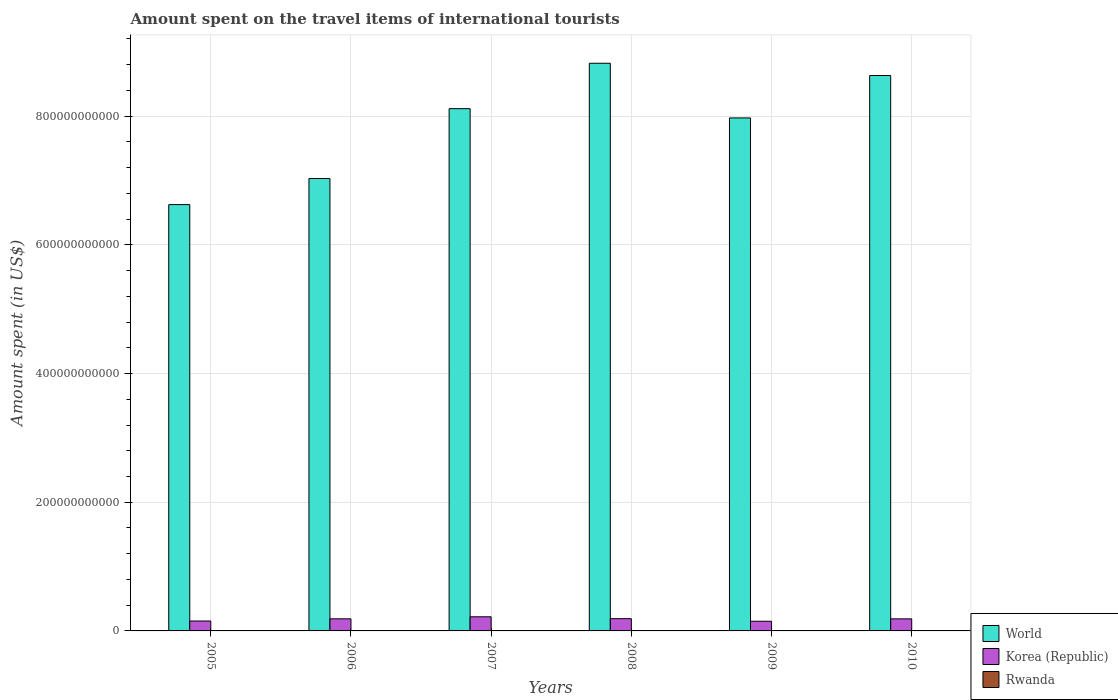How many groups of bars are there?
Provide a short and direct response. 6. Are the number of bars on each tick of the X-axis equal?
Offer a very short reply. Yes. How many bars are there on the 1st tick from the left?
Give a very brief answer. 3. How many bars are there on the 1st tick from the right?
Your answer should be compact. 3. In how many cases, is the number of bars for a given year not equal to the number of legend labels?
Make the answer very short. 0. What is the amount spent on the travel items of international tourists in World in 2006?
Give a very brief answer. 7.03e+11. Across all years, what is the maximum amount spent on the travel items of international tourists in Korea (Republic)?
Offer a very short reply. 2.20e+1. Across all years, what is the minimum amount spent on the travel items of international tourists in World?
Give a very brief answer. 6.63e+11. What is the total amount spent on the travel items of international tourists in Rwanda in the graph?
Provide a succinct answer. 3.44e+08. What is the difference between the amount spent on the travel items of international tourists in Korea (Republic) in 2008 and that in 2010?
Keep it short and to the point. 2.90e+08. What is the difference between the amount spent on the travel items of international tourists in Korea (Republic) in 2010 and the amount spent on the travel items of international tourists in World in 2005?
Your answer should be very brief. -6.44e+11. What is the average amount spent on the travel items of international tourists in Rwanda per year?
Provide a short and direct response. 5.73e+07. In the year 2005, what is the difference between the amount spent on the travel items of international tourists in Korea (Republic) and amount spent on the travel items of international tourists in Rwanda?
Give a very brief answer. 1.54e+1. In how many years, is the amount spent on the travel items of international tourists in Rwanda greater than 200000000000 US$?
Ensure brevity in your answer.  0. What is the ratio of the amount spent on the travel items of international tourists in World in 2007 to that in 2008?
Your answer should be very brief. 0.92. What is the difference between the highest and the second highest amount spent on the travel items of international tourists in Rwanda?
Provide a succinct answer. 5.00e+06. What is the difference between the highest and the lowest amount spent on the travel items of international tourists in World?
Ensure brevity in your answer.  2.20e+11. What does the 3rd bar from the left in 2006 represents?
Your answer should be compact. Rwanda. What does the 1st bar from the right in 2005 represents?
Offer a very short reply. Rwanda. Is it the case that in every year, the sum of the amount spent on the travel items of international tourists in Rwanda and amount spent on the travel items of international tourists in World is greater than the amount spent on the travel items of international tourists in Korea (Republic)?
Keep it short and to the point. Yes. How many bars are there?
Your answer should be compact. 18. Are all the bars in the graph horizontal?
Your answer should be compact. No. What is the difference between two consecutive major ticks on the Y-axis?
Provide a succinct answer. 2.00e+11. Are the values on the major ticks of Y-axis written in scientific E-notation?
Provide a short and direct response. No. Does the graph contain grids?
Offer a terse response. Yes. How many legend labels are there?
Make the answer very short. 3. How are the legend labels stacked?
Give a very brief answer. Vertical. What is the title of the graph?
Your answer should be compact. Amount spent on the travel items of international tourists. Does "Channel Islands" appear as one of the legend labels in the graph?
Provide a short and direct response. No. What is the label or title of the X-axis?
Your answer should be compact. Years. What is the label or title of the Y-axis?
Offer a very short reply. Amount spent (in US$). What is the Amount spent (in US$) in World in 2005?
Make the answer very short. 6.63e+11. What is the Amount spent (in US$) in Korea (Republic) in 2005?
Give a very brief answer. 1.54e+1. What is the Amount spent (in US$) of Rwanda in 2005?
Offer a very short reply. 3.70e+07. What is the Amount spent (in US$) in World in 2006?
Your answer should be very brief. 7.03e+11. What is the Amount spent (in US$) in Korea (Republic) in 2006?
Keep it short and to the point. 1.88e+1. What is the Amount spent (in US$) in Rwanda in 2006?
Offer a very short reply. 4.10e+07. What is the Amount spent (in US$) in World in 2007?
Provide a short and direct response. 8.12e+11. What is the Amount spent (in US$) in Korea (Republic) in 2007?
Your answer should be compact. 2.20e+1. What is the Amount spent (in US$) in Rwanda in 2007?
Provide a succinct answer. 4.70e+07. What is the Amount spent (in US$) in World in 2008?
Your answer should be very brief. 8.82e+11. What is the Amount spent (in US$) of Korea (Republic) in 2008?
Your response must be concise. 1.91e+1. What is the Amount spent (in US$) of Rwanda in 2008?
Give a very brief answer. 7.00e+07. What is the Amount spent (in US$) of World in 2009?
Make the answer very short. 7.97e+11. What is the Amount spent (in US$) in Korea (Republic) in 2009?
Offer a very short reply. 1.50e+1. What is the Amount spent (in US$) in Rwanda in 2009?
Your answer should be very brief. 7.20e+07. What is the Amount spent (in US$) of World in 2010?
Provide a succinct answer. 8.63e+11. What is the Amount spent (in US$) of Korea (Republic) in 2010?
Offer a very short reply. 1.88e+1. What is the Amount spent (in US$) of Rwanda in 2010?
Offer a very short reply. 7.70e+07. Across all years, what is the maximum Amount spent (in US$) in World?
Your response must be concise. 8.82e+11. Across all years, what is the maximum Amount spent (in US$) of Korea (Republic)?
Provide a short and direct response. 2.20e+1. Across all years, what is the maximum Amount spent (in US$) of Rwanda?
Provide a short and direct response. 7.70e+07. Across all years, what is the minimum Amount spent (in US$) of World?
Offer a terse response. 6.63e+11. Across all years, what is the minimum Amount spent (in US$) of Korea (Republic)?
Provide a succinct answer. 1.50e+1. Across all years, what is the minimum Amount spent (in US$) of Rwanda?
Provide a succinct answer. 3.70e+07. What is the total Amount spent (in US$) in World in the graph?
Provide a short and direct response. 4.72e+12. What is the total Amount spent (in US$) in Korea (Republic) in the graph?
Ensure brevity in your answer.  1.09e+11. What is the total Amount spent (in US$) of Rwanda in the graph?
Give a very brief answer. 3.44e+08. What is the difference between the Amount spent (in US$) in World in 2005 and that in 2006?
Offer a terse response. -4.05e+1. What is the difference between the Amount spent (in US$) in Korea (Republic) in 2005 and that in 2006?
Offer a very short reply. -3.40e+09. What is the difference between the Amount spent (in US$) in World in 2005 and that in 2007?
Your response must be concise. -1.49e+11. What is the difference between the Amount spent (in US$) in Korea (Republic) in 2005 and that in 2007?
Provide a succinct answer. -6.55e+09. What is the difference between the Amount spent (in US$) of Rwanda in 2005 and that in 2007?
Provide a short and direct response. -1.00e+07. What is the difference between the Amount spent (in US$) in World in 2005 and that in 2008?
Your answer should be very brief. -2.20e+11. What is the difference between the Amount spent (in US$) in Korea (Republic) in 2005 and that in 2008?
Provide a short and direct response. -3.65e+09. What is the difference between the Amount spent (in US$) of Rwanda in 2005 and that in 2008?
Your answer should be compact. -3.30e+07. What is the difference between the Amount spent (in US$) of World in 2005 and that in 2009?
Give a very brief answer. -1.35e+11. What is the difference between the Amount spent (in US$) of Korea (Republic) in 2005 and that in 2009?
Make the answer very short. 3.71e+08. What is the difference between the Amount spent (in US$) of Rwanda in 2005 and that in 2009?
Your answer should be very brief. -3.50e+07. What is the difference between the Amount spent (in US$) of World in 2005 and that in 2010?
Your answer should be compact. -2.01e+11. What is the difference between the Amount spent (in US$) of Korea (Republic) in 2005 and that in 2010?
Keep it short and to the point. -3.36e+09. What is the difference between the Amount spent (in US$) in Rwanda in 2005 and that in 2010?
Offer a terse response. -4.00e+07. What is the difference between the Amount spent (in US$) of World in 2006 and that in 2007?
Your answer should be compact. -1.09e+11. What is the difference between the Amount spent (in US$) in Korea (Republic) in 2006 and that in 2007?
Your answer should be very brief. -3.15e+09. What is the difference between the Amount spent (in US$) of Rwanda in 2006 and that in 2007?
Make the answer very short. -6.00e+06. What is the difference between the Amount spent (in US$) in World in 2006 and that in 2008?
Provide a short and direct response. -1.79e+11. What is the difference between the Amount spent (in US$) in Korea (Republic) in 2006 and that in 2008?
Your response must be concise. -2.47e+08. What is the difference between the Amount spent (in US$) of Rwanda in 2006 and that in 2008?
Provide a short and direct response. -2.90e+07. What is the difference between the Amount spent (in US$) in World in 2006 and that in 2009?
Your answer should be very brief. -9.41e+1. What is the difference between the Amount spent (in US$) of Korea (Republic) in 2006 and that in 2009?
Ensure brevity in your answer.  3.77e+09. What is the difference between the Amount spent (in US$) in Rwanda in 2006 and that in 2009?
Ensure brevity in your answer.  -3.10e+07. What is the difference between the Amount spent (in US$) in World in 2006 and that in 2010?
Give a very brief answer. -1.60e+11. What is the difference between the Amount spent (in US$) in Korea (Republic) in 2006 and that in 2010?
Your answer should be very brief. 4.30e+07. What is the difference between the Amount spent (in US$) in Rwanda in 2006 and that in 2010?
Offer a terse response. -3.60e+07. What is the difference between the Amount spent (in US$) of World in 2007 and that in 2008?
Provide a short and direct response. -7.06e+1. What is the difference between the Amount spent (in US$) of Korea (Republic) in 2007 and that in 2008?
Keep it short and to the point. 2.90e+09. What is the difference between the Amount spent (in US$) in Rwanda in 2007 and that in 2008?
Offer a very short reply. -2.30e+07. What is the difference between the Amount spent (in US$) of World in 2007 and that in 2009?
Give a very brief answer. 1.44e+1. What is the difference between the Amount spent (in US$) in Korea (Republic) in 2007 and that in 2009?
Ensure brevity in your answer.  6.92e+09. What is the difference between the Amount spent (in US$) in Rwanda in 2007 and that in 2009?
Provide a succinct answer. -2.50e+07. What is the difference between the Amount spent (in US$) of World in 2007 and that in 2010?
Your answer should be compact. -5.15e+1. What is the difference between the Amount spent (in US$) of Korea (Republic) in 2007 and that in 2010?
Your answer should be very brief. 3.19e+09. What is the difference between the Amount spent (in US$) of Rwanda in 2007 and that in 2010?
Ensure brevity in your answer.  -3.00e+07. What is the difference between the Amount spent (in US$) in World in 2008 and that in 2009?
Ensure brevity in your answer.  8.50e+1. What is the difference between the Amount spent (in US$) of Korea (Republic) in 2008 and that in 2009?
Provide a short and direct response. 4.02e+09. What is the difference between the Amount spent (in US$) in Rwanda in 2008 and that in 2009?
Give a very brief answer. -2.00e+06. What is the difference between the Amount spent (in US$) in World in 2008 and that in 2010?
Keep it short and to the point. 1.91e+1. What is the difference between the Amount spent (in US$) of Korea (Republic) in 2008 and that in 2010?
Your answer should be very brief. 2.90e+08. What is the difference between the Amount spent (in US$) in Rwanda in 2008 and that in 2010?
Provide a short and direct response. -7.00e+06. What is the difference between the Amount spent (in US$) of World in 2009 and that in 2010?
Ensure brevity in your answer.  -6.59e+1. What is the difference between the Amount spent (in US$) of Korea (Republic) in 2009 and that in 2010?
Offer a terse response. -3.73e+09. What is the difference between the Amount spent (in US$) of Rwanda in 2009 and that in 2010?
Offer a terse response. -5.00e+06. What is the difference between the Amount spent (in US$) in World in 2005 and the Amount spent (in US$) in Korea (Republic) in 2006?
Offer a terse response. 6.44e+11. What is the difference between the Amount spent (in US$) of World in 2005 and the Amount spent (in US$) of Rwanda in 2006?
Ensure brevity in your answer.  6.62e+11. What is the difference between the Amount spent (in US$) in Korea (Republic) in 2005 and the Amount spent (in US$) in Rwanda in 2006?
Ensure brevity in your answer.  1.54e+1. What is the difference between the Amount spent (in US$) of World in 2005 and the Amount spent (in US$) of Korea (Republic) in 2007?
Offer a very short reply. 6.41e+11. What is the difference between the Amount spent (in US$) of World in 2005 and the Amount spent (in US$) of Rwanda in 2007?
Keep it short and to the point. 6.62e+11. What is the difference between the Amount spent (in US$) of Korea (Republic) in 2005 and the Amount spent (in US$) of Rwanda in 2007?
Give a very brief answer. 1.54e+1. What is the difference between the Amount spent (in US$) in World in 2005 and the Amount spent (in US$) in Korea (Republic) in 2008?
Offer a terse response. 6.43e+11. What is the difference between the Amount spent (in US$) of World in 2005 and the Amount spent (in US$) of Rwanda in 2008?
Your response must be concise. 6.62e+11. What is the difference between the Amount spent (in US$) in Korea (Republic) in 2005 and the Amount spent (in US$) in Rwanda in 2008?
Offer a terse response. 1.53e+1. What is the difference between the Amount spent (in US$) in World in 2005 and the Amount spent (in US$) in Korea (Republic) in 2009?
Make the answer very short. 6.47e+11. What is the difference between the Amount spent (in US$) in World in 2005 and the Amount spent (in US$) in Rwanda in 2009?
Offer a very short reply. 6.62e+11. What is the difference between the Amount spent (in US$) of Korea (Republic) in 2005 and the Amount spent (in US$) of Rwanda in 2009?
Your response must be concise. 1.53e+1. What is the difference between the Amount spent (in US$) in World in 2005 and the Amount spent (in US$) in Korea (Republic) in 2010?
Provide a short and direct response. 6.44e+11. What is the difference between the Amount spent (in US$) in World in 2005 and the Amount spent (in US$) in Rwanda in 2010?
Offer a very short reply. 6.62e+11. What is the difference between the Amount spent (in US$) of Korea (Republic) in 2005 and the Amount spent (in US$) of Rwanda in 2010?
Your response must be concise. 1.53e+1. What is the difference between the Amount spent (in US$) in World in 2006 and the Amount spent (in US$) in Korea (Republic) in 2007?
Your answer should be compact. 6.81e+11. What is the difference between the Amount spent (in US$) of World in 2006 and the Amount spent (in US$) of Rwanda in 2007?
Your answer should be very brief. 7.03e+11. What is the difference between the Amount spent (in US$) of Korea (Republic) in 2006 and the Amount spent (in US$) of Rwanda in 2007?
Provide a succinct answer. 1.88e+1. What is the difference between the Amount spent (in US$) in World in 2006 and the Amount spent (in US$) in Korea (Republic) in 2008?
Provide a succinct answer. 6.84e+11. What is the difference between the Amount spent (in US$) of World in 2006 and the Amount spent (in US$) of Rwanda in 2008?
Offer a terse response. 7.03e+11. What is the difference between the Amount spent (in US$) of Korea (Republic) in 2006 and the Amount spent (in US$) of Rwanda in 2008?
Offer a terse response. 1.87e+1. What is the difference between the Amount spent (in US$) in World in 2006 and the Amount spent (in US$) in Korea (Republic) in 2009?
Keep it short and to the point. 6.88e+11. What is the difference between the Amount spent (in US$) of World in 2006 and the Amount spent (in US$) of Rwanda in 2009?
Give a very brief answer. 7.03e+11. What is the difference between the Amount spent (in US$) of Korea (Republic) in 2006 and the Amount spent (in US$) of Rwanda in 2009?
Provide a short and direct response. 1.87e+1. What is the difference between the Amount spent (in US$) of World in 2006 and the Amount spent (in US$) of Korea (Republic) in 2010?
Provide a succinct answer. 6.84e+11. What is the difference between the Amount spent (in US$) in World in 2006 and the Amount spent (in US$) in Rwanda in 2010?
Your answer should be very brief. 7.03e+11. What is the difference between the Amount spent (in US$) of Korea (Republic) in 2006 and the Amount spent (in US$) of Rwanda in 2010?
Offer a very short reply. 1.87e+1. What is the difference between the Amount spent (in US$) of World in 2007 and the Amount spent (in US$) of Korea (Republic) in 2008?
Your answer should be very brief. 7.93e+11. What is the difference between the Amount spent (in US$) of World in 2007 and the Amount spent (in US$) of Rwanda in 2008?
Your response must be concise. 8.12e+11. What is the difference between the Amount spent (in US$) in Korea (Republic) in 2007 and the Amount spent (in US$) in Rwanda in 2008?
Ensure brevity in your answer.  2.19e+1. What is the difference between the Amount spent (in US$) in World in 2007 and the Amount spent (in US$) in Korea (Republic) in 2009?
Your answer should be compact. 7.97e+11. What is the difference between the Amount spent (in US$) of World in 2007 and the Amount spent (in US$) of Rwanda in 2009?
Make the answer very short. 8.12e+11. What is the difference between the Amount spent (in US$) of Korea (Republic) in 2007 and the Amount spent (in US$) of Rwanda in 2009?
Keep it short and to the point. 2.19e+1. What is the difference between the Amount spent (in US$) in World in 2007 and the Amount spent (in US$) in Korea (Republic) in 2010?
Your response must be concise. 7.93e+11. What is the difference between the Amount spent (in US$) of World in 2007 and the Amount spent (in US$) of Rwanda in 2010?
Offer a terse response. 8.12e+11. What is the difference between the Amount spent (in US$) in Korea (Republic) in 2007 and the Amount spent (in US$) in Rwanda in 2010?
Make the answer very short. 2.19e+1. What is the difference between the Amount spent (in US$) of World in 2008 and the Amount spent (in US$) of Korea (Republic) in 2009?
Offer a terse response. 8.67e+11. What is the difference between the Amount spent (in US$) of World in 2008 and the Amount spent (in US$) of Rwanda in 2009?
Make the answer very short. 8.82e+11. What is the difference between the Amount spent (in US$) of Korea (Republic) in 2008 and the Amount spent (in US$) of Rwanda in 2009?
Your answer should be very brief. 1.90e+1. What is the difference between the Amount spent (in US$) in World in 2008 and the Amount spent (in US$) in Korea (Republic) in 2010?
Give a very brief answer. 8.63e+11. What is the difference between the Amount spent (in US$) in World in 2008 and the Amount spent (in US$) in Rwanda in 2010?
Your response must be concise. 8.82e+11. What is the difference between the Amount spent (in US$) in Korea (Republic) in 2008 and the Amount spent (in US$) in Rwanda in 2010?
Provide a succinct answer. 1.90e+1. What is the difference between the Amount spent (in US$) of World in 2009 and the Amount spent (in US$) of Korea (Republic) in 2010?
Provide a succinct answer. 7.78e+11. What is the difference between the Amount spent (in US$) in World in 2009 and the Amount spent (in US$) in Rwanda in 2010?
Your answer should be very brief. 7.97e+11. What is the difference between the Amount spent (in US$) in Korea (Republic) in 2009 and the Amount spent (in US$) in Rwanda in 2010?
Offer a terse response. 1.50e+1. What is the average Amount spent (in US$) of World per year?
Your answer should be very brief. 7.87e+11. What is the average Amount spent (in US$) in Korea (Republic) per year?
Your answer should be very brief. 1.82e+1. What is the average Amount spent (in US$) in Rwanda per year?
Your answer should be compact. 5.73e+07. In the year 2005, what is the difference between the Amount spent (in US$) in World and Amount spent (in US$) in Korea (Republic)?
Offer a terse response. 6.47e+11. In the year 2005, what is the difference between the Amount spent (in US$) of World and Amount spent (in US$) of Rwanda?
Offer a terse response. 6.62e+11. In the year 2005, what is the difference between the Amount spent (in US$) of Korea (Republic) and Amount spent (in US$) of Rwanda?
Ensure brevity in your answer.  1.54e+1. In the year 2006, what is the difference between the Amount spent (in US$) in World and Amount spent (in US$) in Korea (Republic)?
Your answer should be very brief. 6.84e+11. In the year 2006, what is the difference between the Amount spent (in US$) in World and Amount spent (in US$) in Rwanda?
Provide a succinct answer. 7.03e+11. In the year 2006, what is the difference between the Amount spent (in US$) in Korea (Republic) and Amount spent (in US$) in Rwanda?
Your answer should be compact. 1.88e+1. In the year 2007, what is the difference between the Amount spent (in US$) in World and Amount spent (in US$) in Korea (Republic)?
Your answer should be compact. 7.90e+11. In the year 2007, what is the difference between the Amount spent (in US$) in World and Amount spent (in US$) in Rwanda?
Keep it short and to the point. 8.12e+11. In the year 2007, what is the difference between the Amount spent (in US$) in Korea (Republic) and Amount spent (in US$) in Rwanda?
Provide a short and direct response. 2.19e+1. In the year 2008, what is the difference between the Amount spent (in US$) in World and Amount spent (in US$) in Korea (Republic)?
Provide a succinct answer. 8.63e+11. In the year 2008, what is the difference between the Amount spent (in US$) in World and Amount spent (in US$) in Rwanda?
Your answer should be compact. 8.82e+11. In the year 2008, what is the difference between the Amount spent (in US$) of Korea (Republic) and Amount spent (in US$) of Rwanda?
Make the answer very short. 1.90e+1. In the year 2009, what is the difference between the Amount spent (in US$) of World and Amount spent (in US$) of Korea (Republic)?
Ensure brevity in your answer.  7.82e+11. In the year 2009, what is the difference between the Amount spent (in US$) of World and Amount spent (in US$) of Rwanda?
Your answer should be very brief. 7.97e+11. In the year 2009, what is the difference between the Amount spent (in US$) in Korea (Republic) and Amount spent (in US$) in Rwanda?
Ensure brevity in your answer.  1.50e+1. In the year 2010, what is the difference between the Amount spent (in US$) of World and Amount spent (in US$) of Korea (Republic)?
Ensure brevity in your answer.  8.44e+11. In the year 2010, what is the difference between the Amount spent (in US$) in World and Amount spent (in US$) in Rwanda?
Your answer should be compact. 8.63e+11. In the year 2010, what is the difference between the Amount spent (in US$) in Korea (Republic) and Amount spent (in US$) in Rwanda?
Offer a terse response. 1.87e+1. What is the ratio of the Amount spent (in US$) of World in 2005 to that in 2006?
Keep it short and to the point. 0.94. What is the ratio of the Amount spent (in US$) of Korea (Republic) in 2005 to that in 2006?
Offer a terse response. 0.82. What is the ratio of the Amount spent (in US$) of Rwanda in 2005 to that in 2006?
Provide a short and direct response. 0.9. What is the ratio of the Amount spent (in US$) in World in 2005 to that in 2007?
Make the answer very short. 0.82. What is the ratio of the Amount spent (in US$) of Korea (Republic) in 2005 to that in 2007?
Provide a short and direct response. 0.7. What is the ratio of the Amount spent (in US$) of Rwanda in 2005 to that in 2007?
Your answer should be very brief. 0.79. What is the ratio of the Amount spent (in US$) of World in 2005 to that in 2008?
Provide a short and direct response. 0.75. What is the ratio of the Amount spent (in US$) of Korea (Republic) in 2005 to that in 2008?
Provide a short and direct response. 0.81. What is the ratio of the Amount spent (in US$) of Rwanda in 2005 to that in 2008?
Give a very brief answer. 0.53. What is the ratio of the Amount spent (in US$) of World in 2005 to that in 2009?
Give a very brief answer. 0.83. What is the ratio of the Amount spent (in US$) in Korea (Republic) in 2005 to that in 2009?
Provide a succinct answer. 1.02. What is the ratio of the Amount spent (in US$) of Rwanda in 2005 to that in 2009?
Make the answer very short. 0.51. What is the ratio of the Amount spent (in US$) of World in 2005 to that in 2010?
Offer a terse response. 0.77. What is the ratio of the Amount spent (in US$) of Korea (Republic) in 2005 to that in 2010?
Your answer should be compact. 0.82. What is the ratio of the Amount spent (in US$) in Rwanda in 2005 to that in 2010?
Provide a short and direct response. 0.48. What is the ratio of the Amount spent (in US$) of World in 2006 to that in 2007?
Your response must be concise. 0.87. What is the ratio of the Amount spent (in US$) in Korea (Republic) in 2006 to that in 2007?
Your response must be concise. 0.86. What is the ratio of the Amount spent (in US$) of Rwanda in 2006 to that in 2007?
Keep it short and to the point. 0.87. What is the ratio of the Amount spent (in US$) in World in 2006 to that in 2008?
Your answer should be very brief. 0.8. What is the ratio of the Amount spent (in US$) in Korea (Republic) in 2006 to that in 2008?
Ensure brevity in your answer.  0.99. What is the ratio of the Amount spent (in US$) in Rwanda in 2006 to that in 2008?
Your answer should be compact. 0.59. What is the ratio of the Amount spent (in US$) of World in 2006 to that in 2009?
Your response must be concise. 0.88. What is the ratio of the Amount spent (in US$) of Korea (Republic) in 2006 to that in 2009?
Your answer should be very brief. 1.25. What is the ratio of the Amount spent (in US$) of Rwanda in 2006 to that in 2009?
Make the answer very short. 0.57. What is the ratio of the Amount spent (in US$) of World in 2006 to that in 2010?
Your answer should be compact. 0.81. What is the ratio of the Amount spent (in US$) of Korea (Republic) in 2006 to that in 2010?
Provide a succinct answer. 1. What is the ratio of the Amount spent (in US$) in Rwanda in 2006 to that in 2010?
Provide a succinct answer. 0.53. What is the ratio of the Amount spent (in US$) of Korea (Republic) in 2007 to that in 2008?
Your answer should be compact. 1.15. What is the ratio of the Amount spent (in US$) of Rwanda in 2007 to that in 2008?
Provide a succinct answer. 0.67. What is the ratio of the Amount spent (in US$) in World in 2007 to that in 2009?
Your answer should be very brief. 1.02. What is the ratio of the Amount spent (in US$) in Korea (Republic) in 2007 to that in 2009?
Make the answer very short. 1.46. What is the ratio of the Amount spent (in US$) in Rwanda in 2007 to that in 2009?
Keep it short and to the point. 0.65. What is the ratio of the Amount spent (in US$) of World in 2007 to that in 2010?
Provide a short and direct response. 0.94. What is the ratio of the Amount spent (in US$) of Korea (Republic) in 2007 to that in 2010?
Make the answer very short. 1.17. What is the ratio of the Amount spent (in US$) in Rwanda in 2007 to that in 2010?
Your answer should be compact. 0.61. What is the ratio of the Amount spent (in US$) of World in 2008 to that in 2009?
Give a very brief answer. 1.11. What is the ratio of the Amount spent (in US$) in Korea (Republic) in 2008 to that in 2009?
Provide a short and direct response. 1.27. What is the ratio of the Amount spent (in US$) of Rwanda in 2008 to that in 2009?
Offer a very short reply. 0.97. What is the ratio of the Amount spent (in US$) in World in 2008 to that in 2010?
Provide a succinct answer. 1.02. What is the ratio of the Amount spent (in US$) in Korea (Republic) in 2008 to that in 2010?
Ensure brevity in your answer.  1.02. What is the ratio of the Amount spent (in US$) of World in 2009 to that in 2010?
Your answer should be compact. 0.92. What is the ratio of the Amount spent (in US$) of Korea (Republic) in 2009 to that in 2010?
Your answer should be very brief. 0.8. What is the ratio of the Amount spent (in US$) in Rwanda in 2009 to that in 2010?
Give a very brief answer. 0.94. What is the difference between the highest and the second highest Amount spent (in US$) in World?
Your response must be concise. 1.91e+1. What is the difference between the highest and the second highest Amount spent (in US$) of Korea (Republic)?
Your answer should be compact. 2.90e+09. What is the difference between the highest and the lowest Amount spent (in US$) in World?
Offer a very short reply. 2.20e+11. What is the difference between the highest and the lowest Amount spent (in US$) in Korea (Republic)?
Ensure brevity in your answer.  6.92e+09. What is the difference between the highest and the lowest Amount spent (in US$) in Rwanda?
Offer a very short reply. 4.00e+07. 